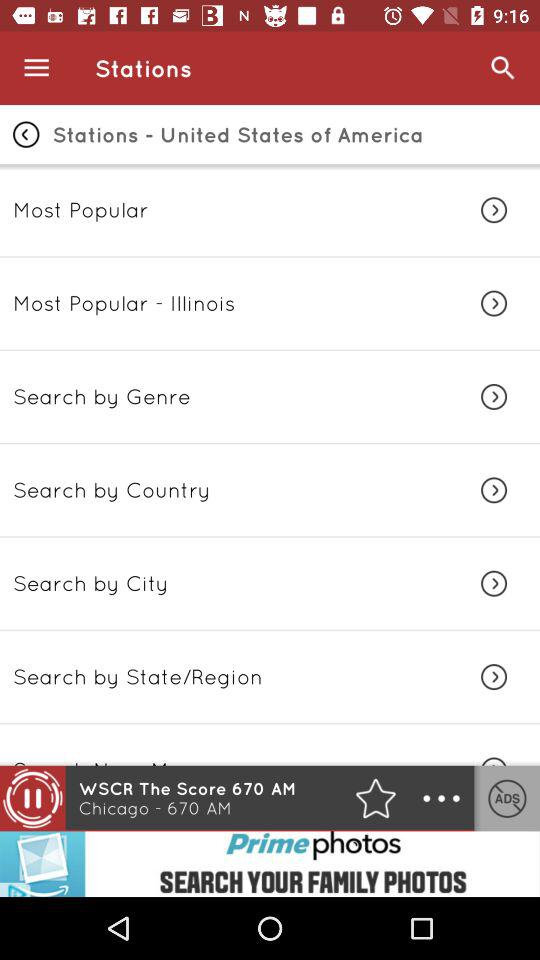What's the current playing station Frequency?
When the provided information is insufficient, respond with <no answer>. <no answer> 